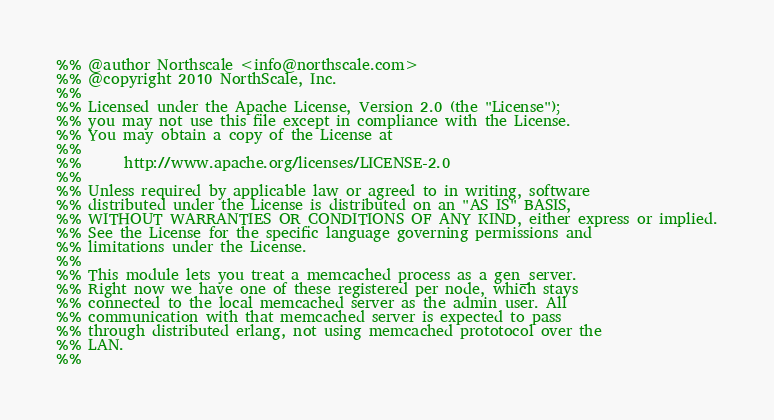<code> <loc_0><loc_0><loc_500><loc_500><_Erlang_>%% @author Northscale <info@northscale.com>
%% @copyright 2010 NorthScale, Inc.
%%
%% Licensed under the Apache License, Version 2.0 (the "License");
%% you may not use this file except in compliance with the License.
%% You may obtain a copy of the License at
%%
%%      http://www.apache.org/licenses/LICENSE-2.0
%%
%% Unless required by applicable law or agreed to in writing, software
%% distributed under the License is distributed on an "AS IS" BASIS,
%% WITHOUT WARRANTIES OR CONDITIONS OF ANY KIND, either express or implied.
%% See the License for the specific language governing permissions and
%% limitations under the License.
%%
%% This module lets you treat a memcached process as a gen_server.
%% Right now we have one of these registered per node, which stays
%% connected to the local memcached server as the admin user. All
%% communication with that memcached server is expected to pass
%% through distributed erlang, not using memcached prototocol over the
%% LAN.
%%</code> 